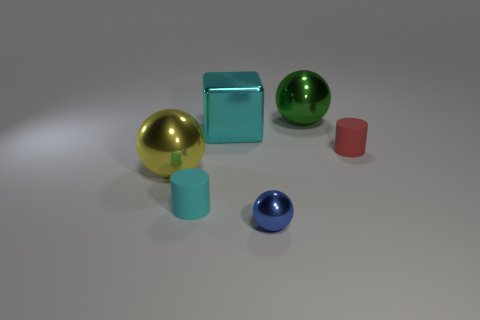What number of things are either small red objects or big objects?
Provide a short and direct response. 4. What shape is the tiny object that is made of the same material as the large yellow sphere?
Offer a very short reply. Sphere. How many small objects are green metallic balls or blue shiny objects?
Ensure brevity in your answer.  1. How many other objects are there of the same color as the big cube?
Your response must be concise. 1. There is a sphere that is behind the large metal sphere that is in front of the large green metallic thing; how many cyan shiny things are behind it?
Your answer should be compact. 0. Do the matte object right of the blue metal sphere and the tiny cyan rubber cylinder have the same size?
Offer a terse response. Yes. Is the number of tiny cylinders that are to the right of the big green metal thing less than the number of green things that are left of the yellow metallic ball?
Offer a very short reply. No. Do the large block and the small metallic sphere have the same color?
Ensure brevity in your answer.  No. Are there fewer green spheres that are in front of the large yellow ball than red rubber cylinders?
Keep it short and to the point. Yes. There is a small cylinder that is the same color as the large cube; what is it made of?
Offer a very short reply. Rubber. 